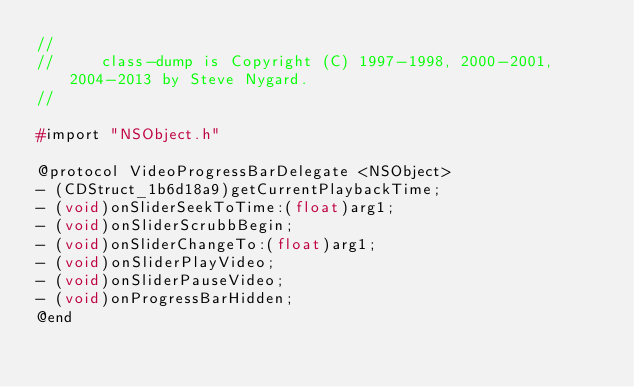<code> <loc_0><loc_0><loc_500><loc_500><_C_>//
//     class-dump is Copyright (C) 1997-1998, 2000-2001, 2004-2013 by Steve Nygard.
//

#import "NSObject.h"

@protocol VideoProgressBarDelegate <NSObject>
- (CDStruct_1b6d18a9)getCurrentPlaybackTime;
- (void)onSliderSeekToTime:(float)arg1;
- (void)onSliderScrubbBegin;
- (void)onSliderChangeTo:(float)arg1;
- (void)onSliderPlayVideo;
- (void)onSliderPauseVideo;
- (void)onProgressBarHidden;
@end

</code> 